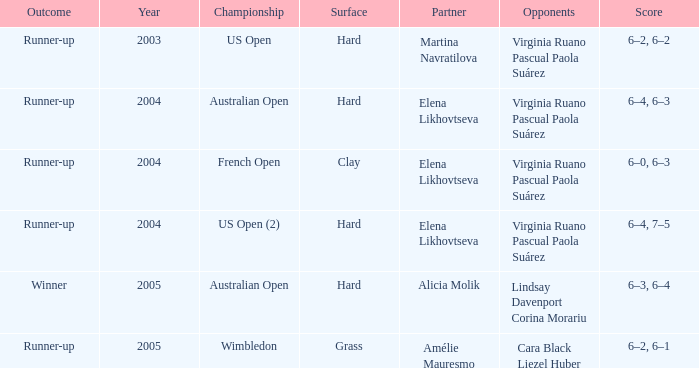When winner is the outcome what is the score? 6–3, 6–4. 